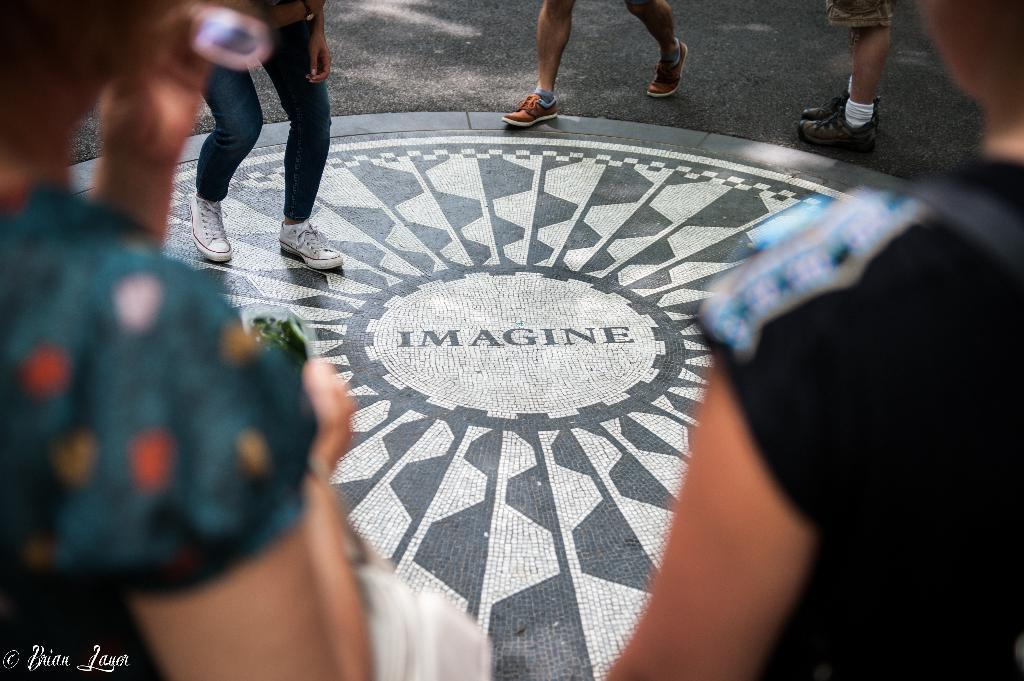What is happening in the image? There are persons standing on the road in the image. Can you describe the setting of the image? The setting is a road where people are standing. How many people are visible in the image? The number of people is not specified, but there are persons standing on the road. What type of wine is being served at the team's celebration in the image? There is no team, celebration, or wine present in the image; it only shows persons standing on the road. 